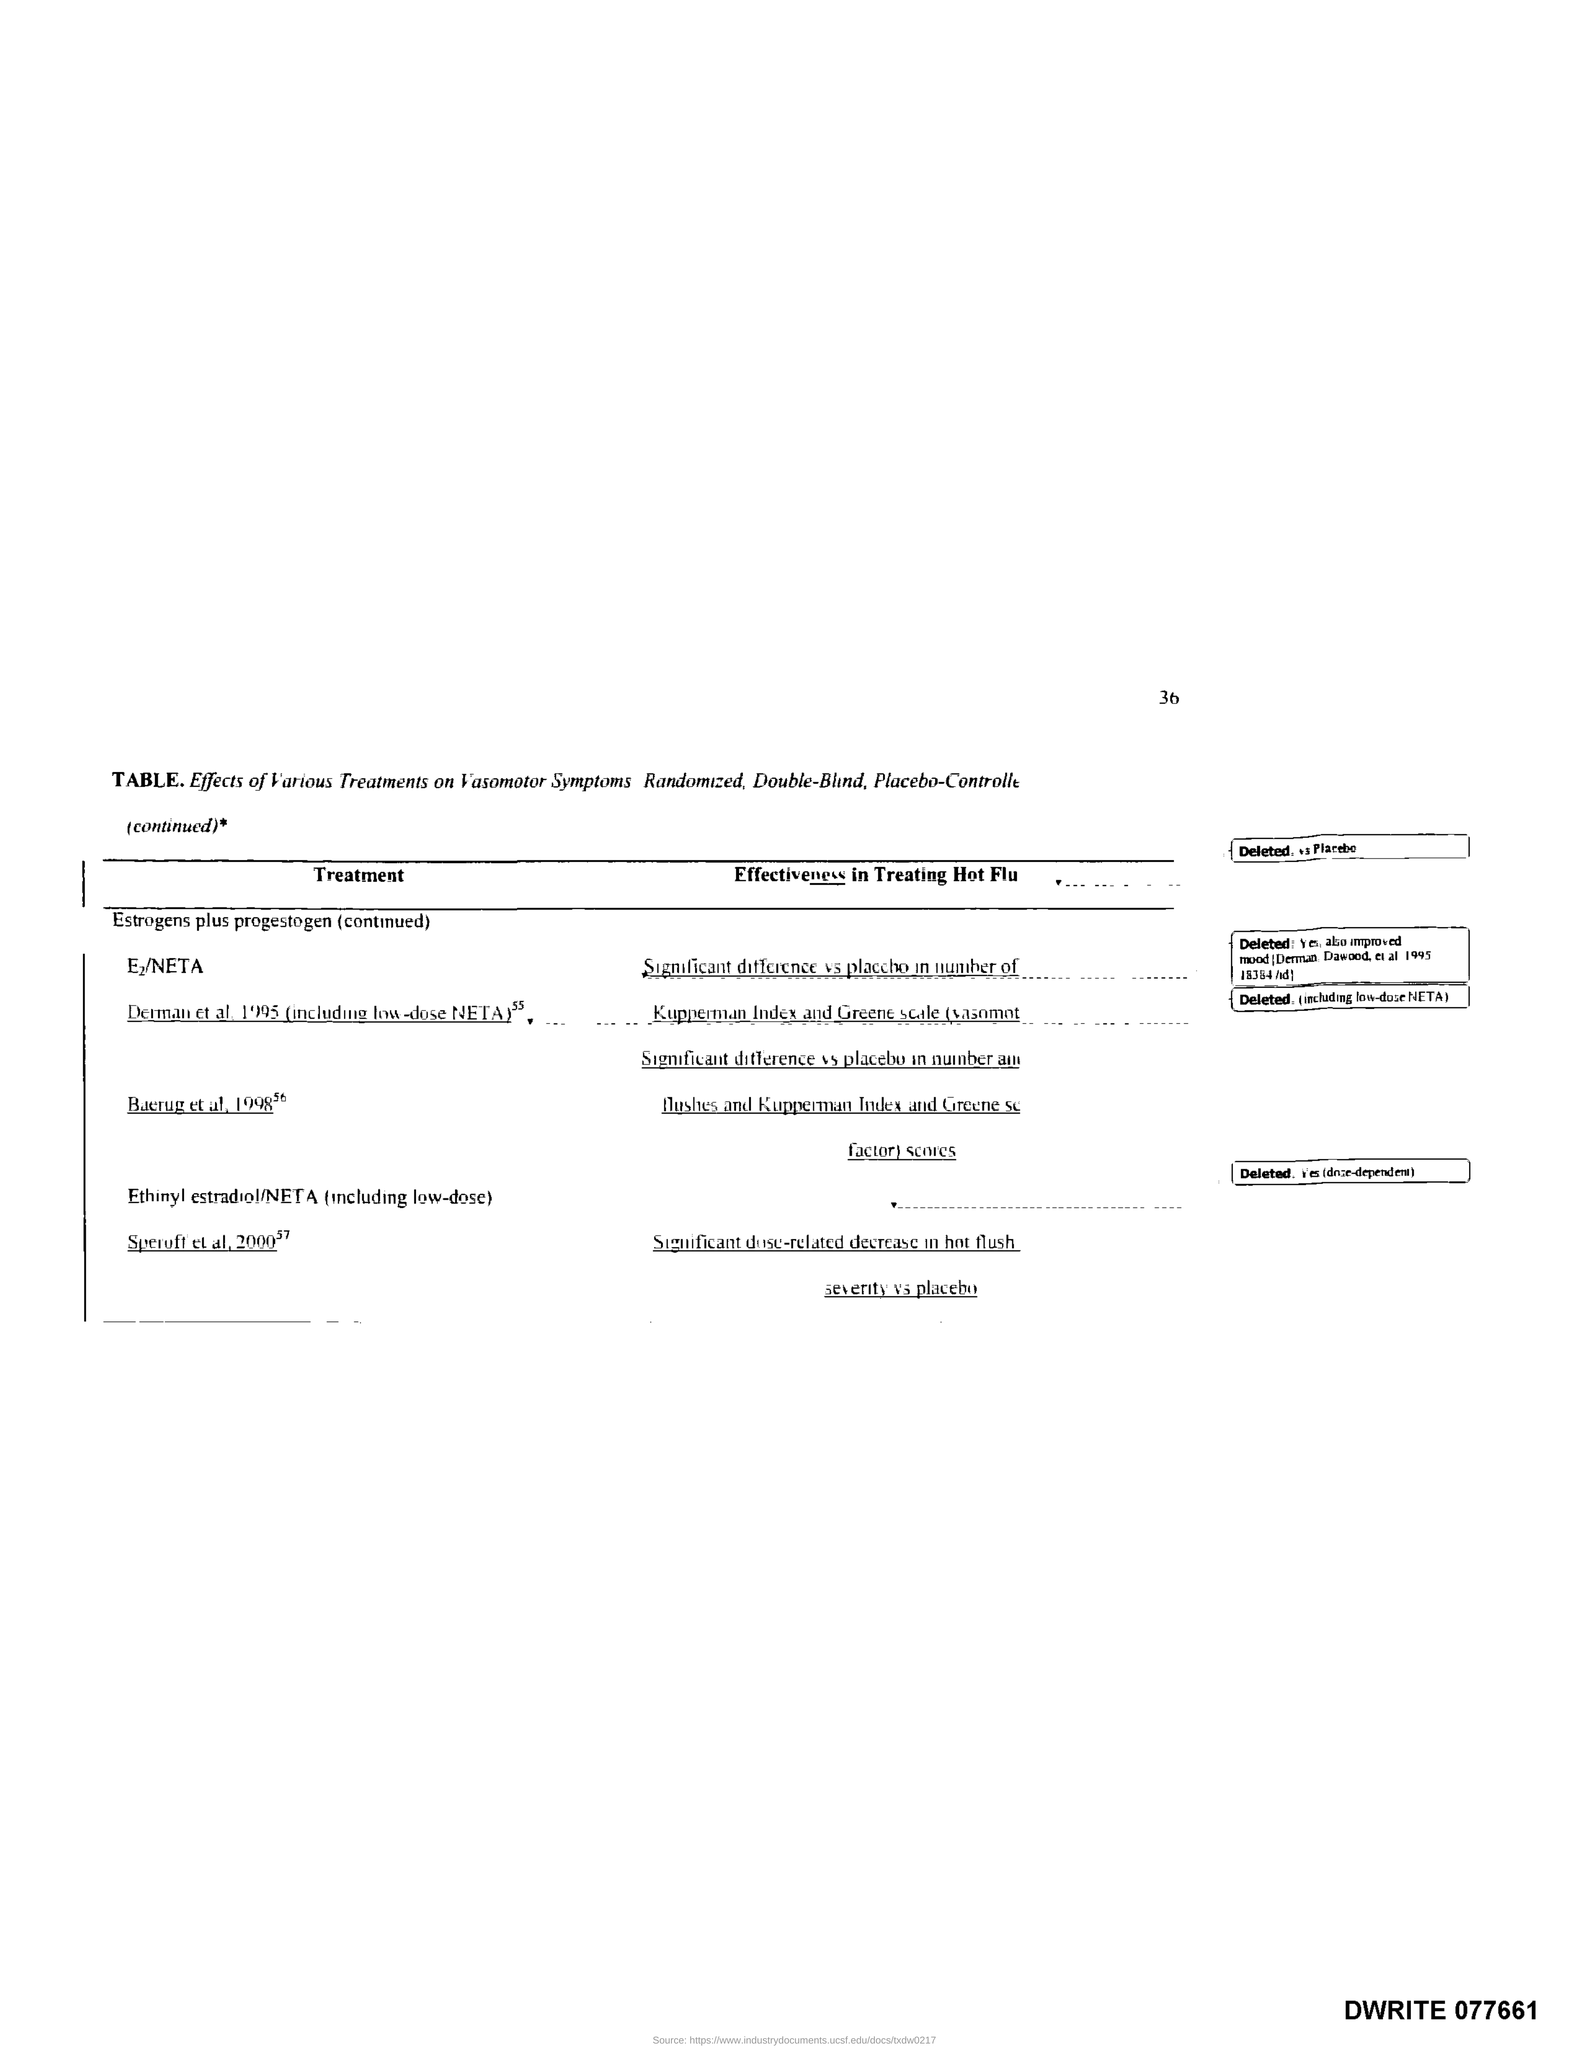What is the Page Number?
Provide a succinct answer. 36. 